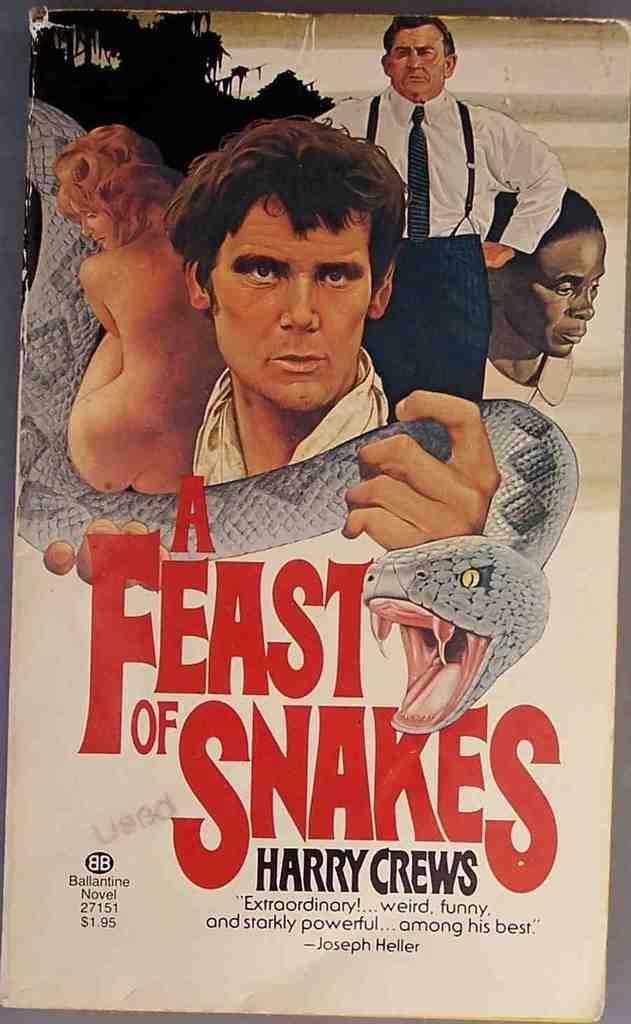<image>
Write a terse but informative summary of the picture. a poster that says 'a feast of snakes' on it 